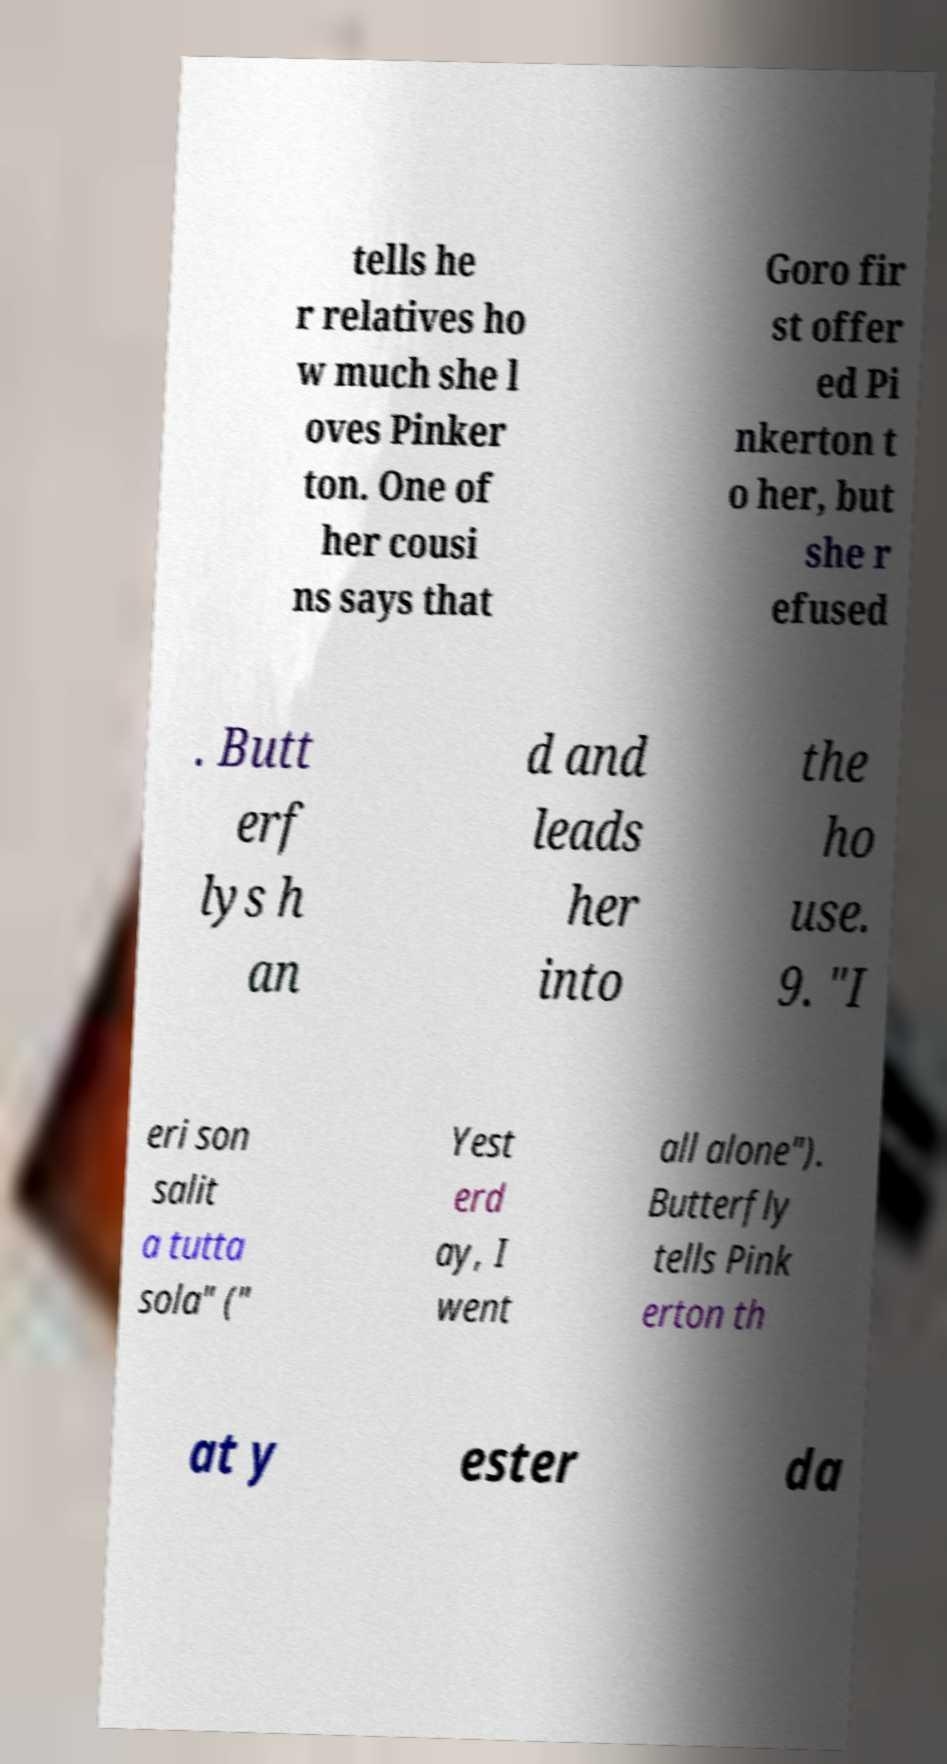Please read and relay the text visible in this image. What does it say? tells he r relatives ho w much she l oves Pinker ton. One of her cousi ns says that Goro fir st offer ed Pi nkerton t o her, but she r efused . Butt erf lys h an d and leads her into the ho use. 9. "I eri son salit a tutta sola" (" Yest erd ay, I went all alone"). Butterfly tells Pink erton th at y ester da 